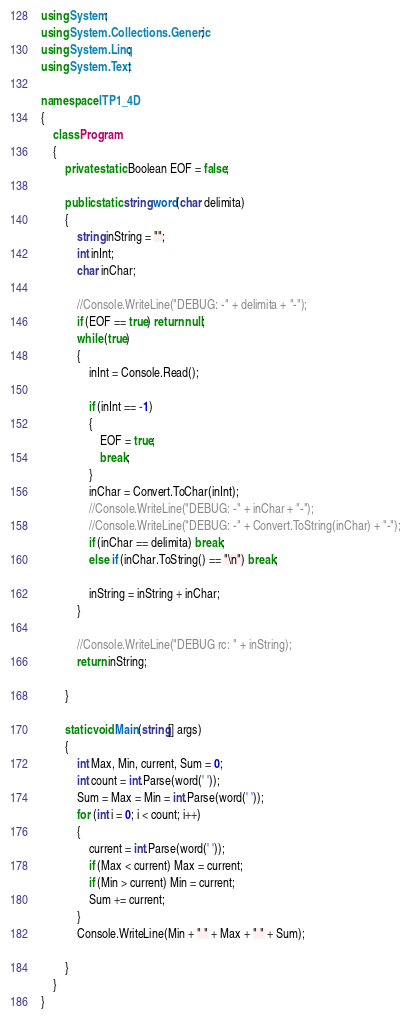Convert code to text. <code><loc_0><loc_0><loc_500><loc_500><_C#_>using System;
using System.Collections.Generic;
using System.Linq;
using System.Text;

namespace ITP1_4D
{
    class Program
    {
        private static Boolean EOF = false;

        public static string word(char delimita)
        {
            string inString = "";
            int inInt;
            char inChar;

            //Console.WriteLine("DEBUG: -" + delimita + "-");
            if (EOF == true) return null;
            while (true)
            {
                inInt = Console.Read();
                
                if (inInt == -1)
                {
                    EOF = true;
                    break;
                }
                inChar = Convert.ToChar(inInt);
                //Console.WriteLine("DEBUG: -" + inChar + "-");
                //Console.WriteLine("DEBUG: -" + Convert.ToString(inChar) + "-");
                if (inChar == delimita) break;
                else if (inChar.ToString() == "\n") break;

                inString = inString + inChar;
            }

            //Console.WriteLine("DEBUG rc: " + inString);
            return inString;

        }

        static void Main(string[] args)
        {
            int Max, Min, current, Sum = 0;
            int count = int.Parse(word(' '));
            Sum = Max = Min = int.Parse(word(' '));
            for (int i = 0; i < count; i++)
            {
                current = int.Parse(word(' '));
                if (Max < current) Max = current;
                if (Min > current) Min = current;
                Sum += current;
            }
            Console.WriteLine(Min + " " + Max + " " + Sum);

        }
    }
}</code> 